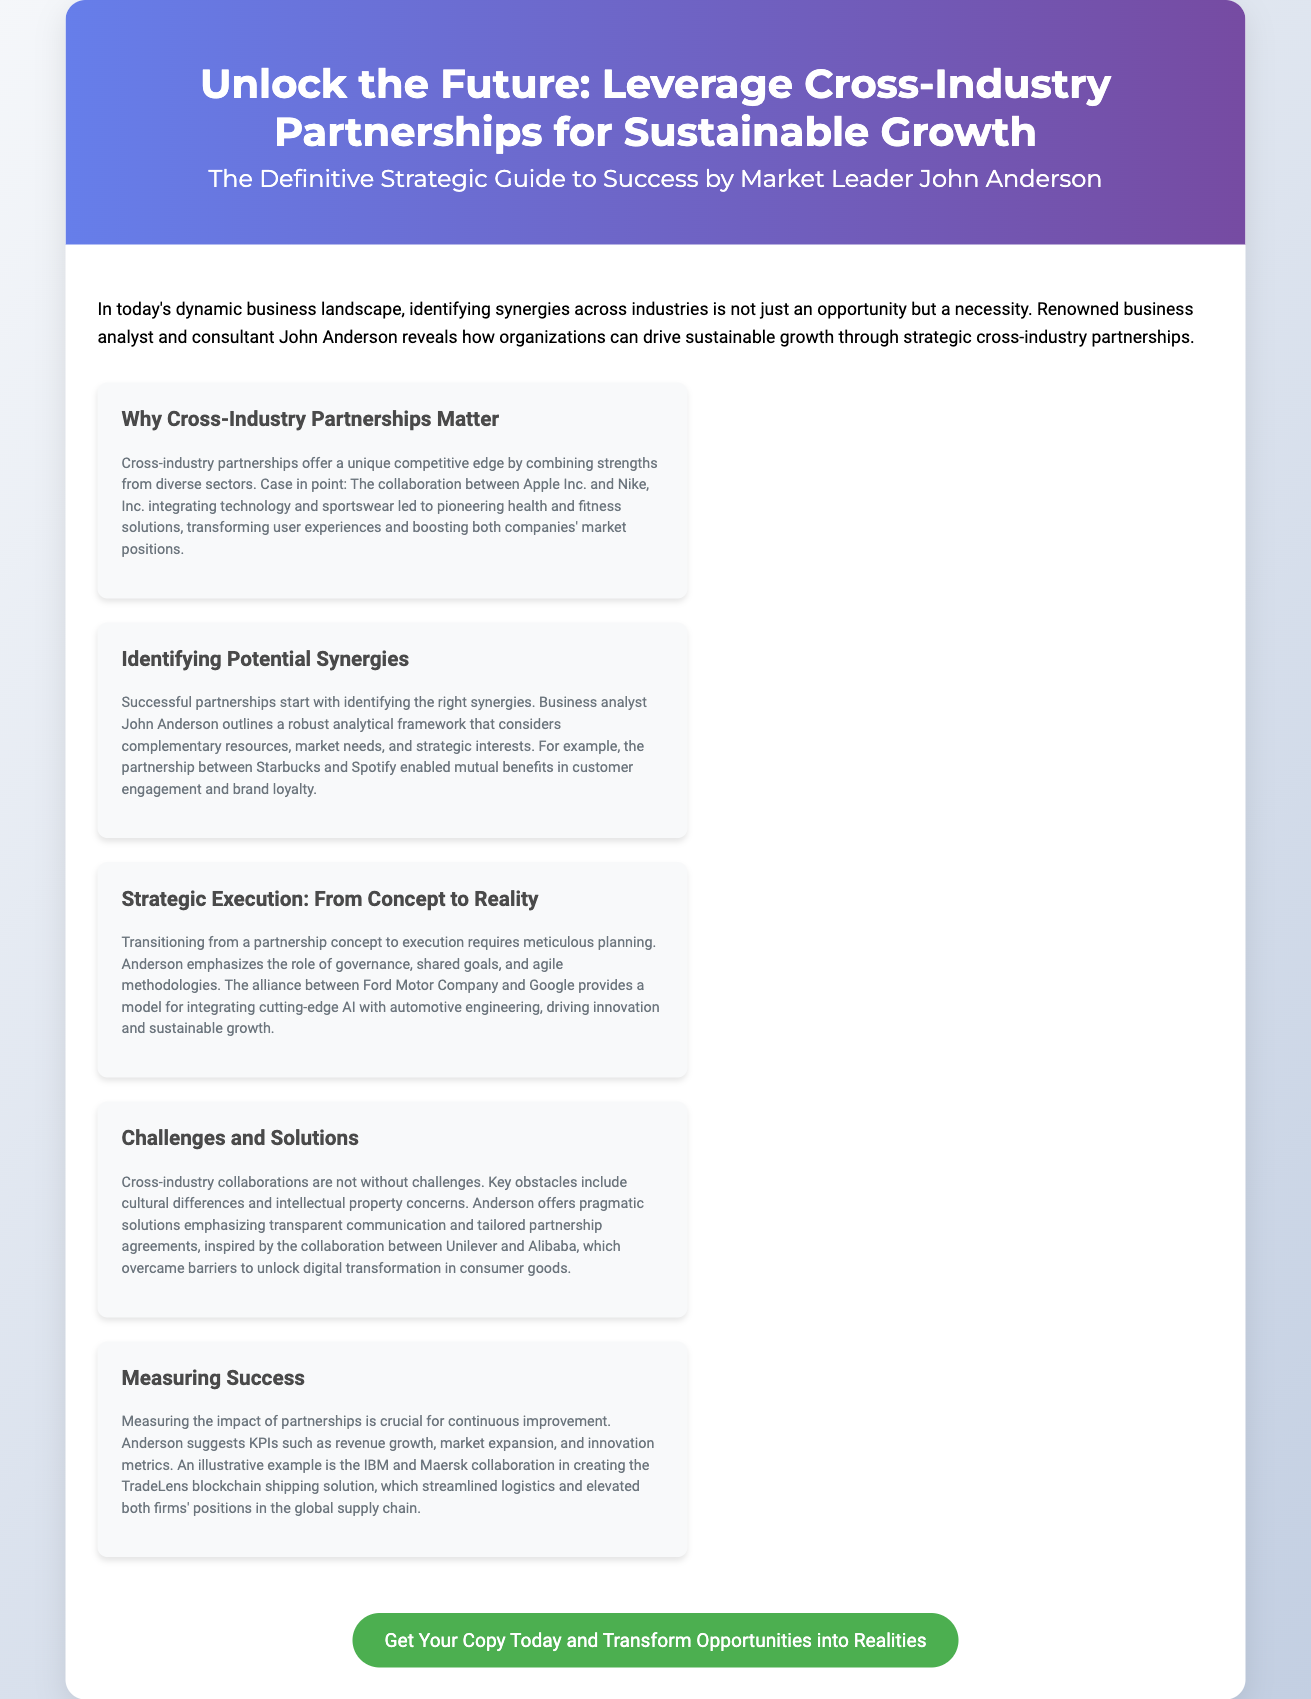what is the title of the guide? The title of the guide is presented prominently in the document header section.
Answer: Leveraging Cross-Industry Partnerships for Sustainable Growth who is the author of the guide? The guide's author is stated directly under the title in the header.
Answer: John Anderson what is one example of a successful cross-industry partnership mentioned? The document provides an example of a partnership that combines strengths from different sectors to illustrate its points.
Answer: Apple Inc. and Nike, Inc what framework does John Anderson outline for identifying synergies? The document refers to the analytical framework mentioned by Anderson for forming partnerships.
Answer: A robust analytical framework which two companies collaborated to create the TradeLens blockchain solution? The document discusses a specific partnership focused on logistics and blockchain technology.
Answer: IBM and Maersk what challenge is emphasized regarding cross-industry collaborations? The document lists specific challenges faced in partnerships that involve different industries.
Answer: Cultural differences how does John Anderson suggest measuring the impact of partnerships? The document mentions key performance indicators related to tracking partnership success.
Answer: KPIs such as revenue growth what type of methodologies does Anderson emphasize for executing partnerships? The document highlights approaches necessary for successful implementation of partnerships.
Answer: Agile methodologies 